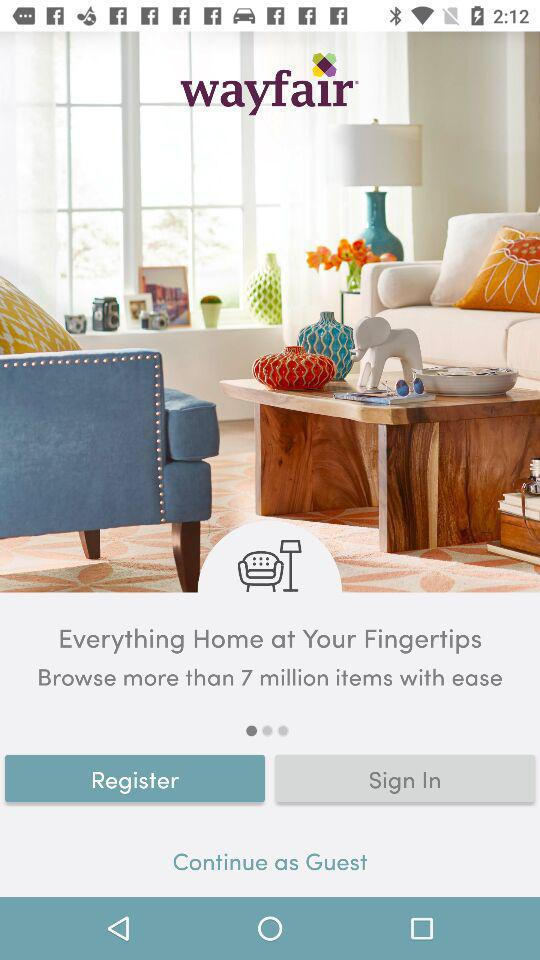How many items can we browse? You can browse more than 7 million items. 